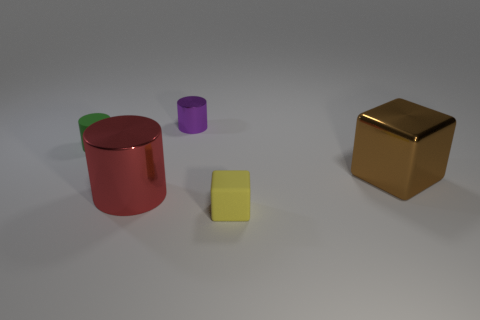Add 3 big red rubber cylinders. How many objects exist? 8 Subtract all cylinders. How many objects are left? 2 Add 1 large brown metal objects. How many large brown metal objects exist? 2 Subtract 1 green cylinders. How many objects are left? 4 Subtract all large yellow rubber spheres. Subtract all large red metal cylinders. How many objects are left? 4 Add 3 rubber objects. How many rubber objects are left? 5 